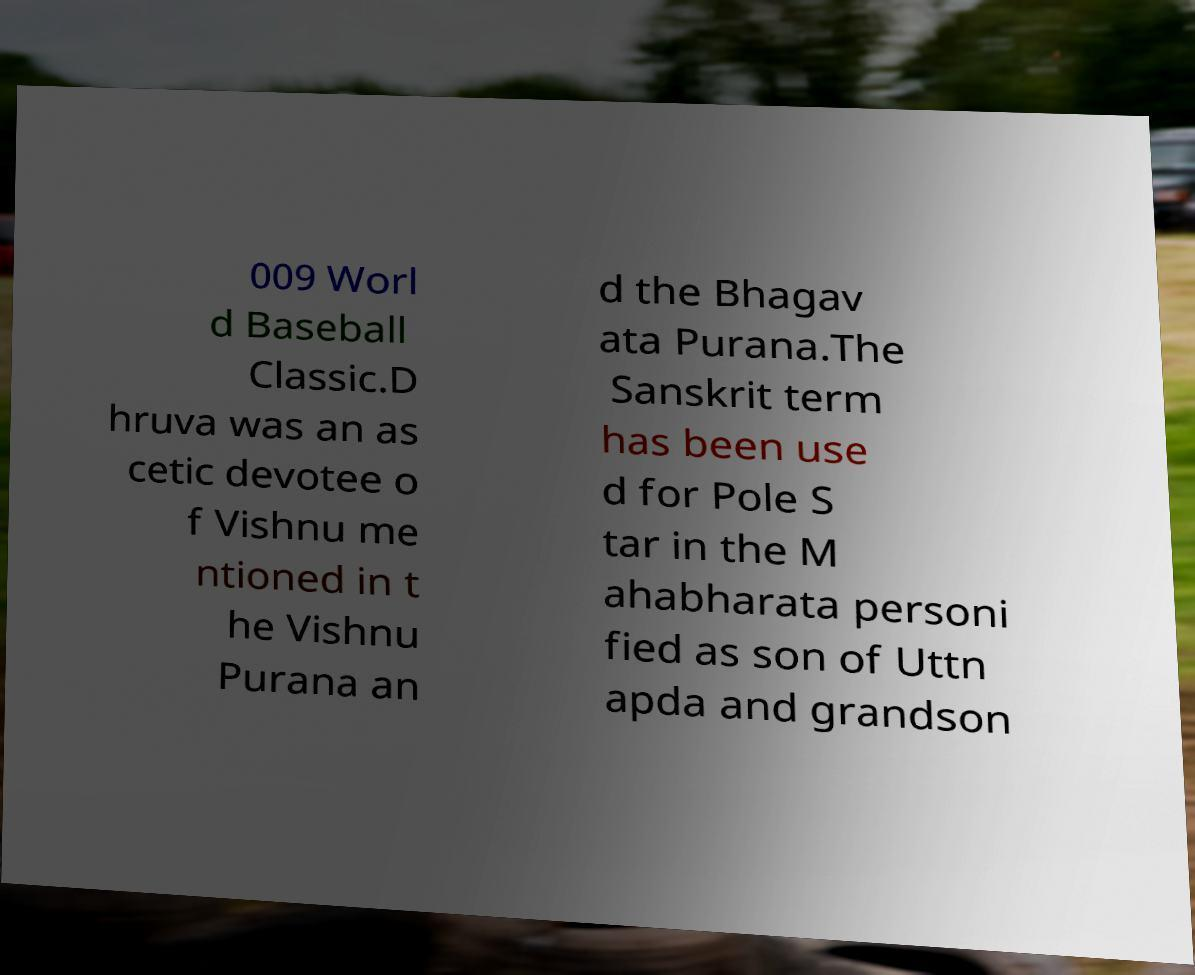Please identify and transcribe the text found in this image. 009 Worl d Baseball Classic.D hruva was an as cetic devotee o f Vishnu me ntioned in t he Vishnu Purana an d the Bhagav ata Purana.The Sanskrit term has been use d for Pole S tar in the M ahabharata personi fied as son of Uttn apda and grandson 